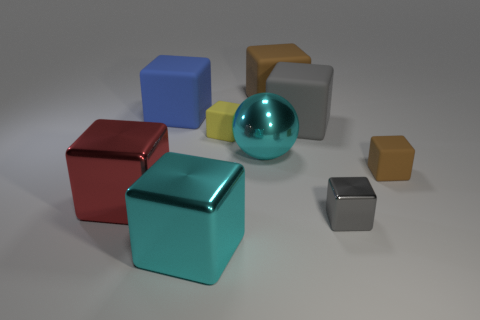How many gray matte things have the same size as the gray metal thing?
Provide a succinct answer. 0. There is a big cyan object that is the same shape as the small yellow thing; what is it made of?
Offer a terse response. Metal. There is a large thing right of the big brown matte block; is it the same color as the metallic block right of the cyan metal ball?
Offer a terse response. Yes. What is the shape of the cyan metallic thing to the left of the large metallic sphere?
Offer a very short reply. Cube. The sphere has what color?
Your answer should be very brief. Cyan. What shape is the large red object that is the same material as the small gray block?
Keep it short and to the point. Cube. Is the size of the brown thing that is in front of the yellow matte block the same as the yellow rubber cube?
Your answer should be very brief. Yes. What number of objects are either big metallic cubes behind the tiny gray metallic cube or objects to the left of the cyan shiny ball?
Your response must be concise. 4. Is the color of the big matte cube that is in front of the blue matte thing the same as the small metal cube?
Offer a terse response. Yes. How many rubber objects are either big red blocks or cyan objects?
Offer a terse response. 0. 